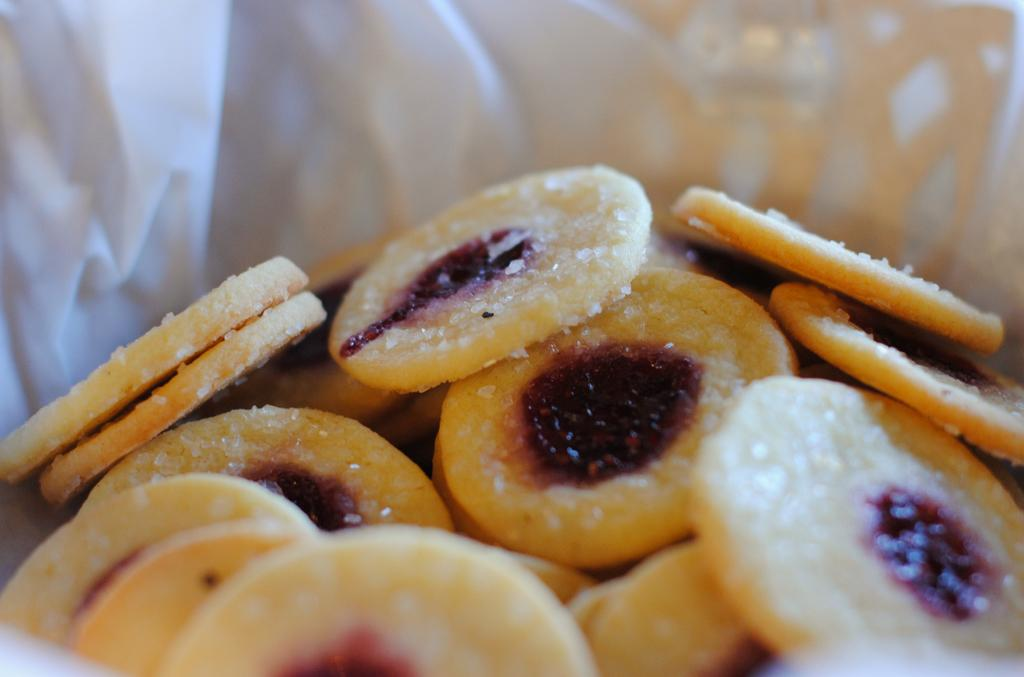What type of food can be seen in the image? There are cookies in the image. How are the cookies arranged or presented in the image? The cookies are placed in a bowl. What channel is the hydrant tuned to in the image? There is no hydrant present in the image, so it is not possible to determine what channel it might be tuned to. 